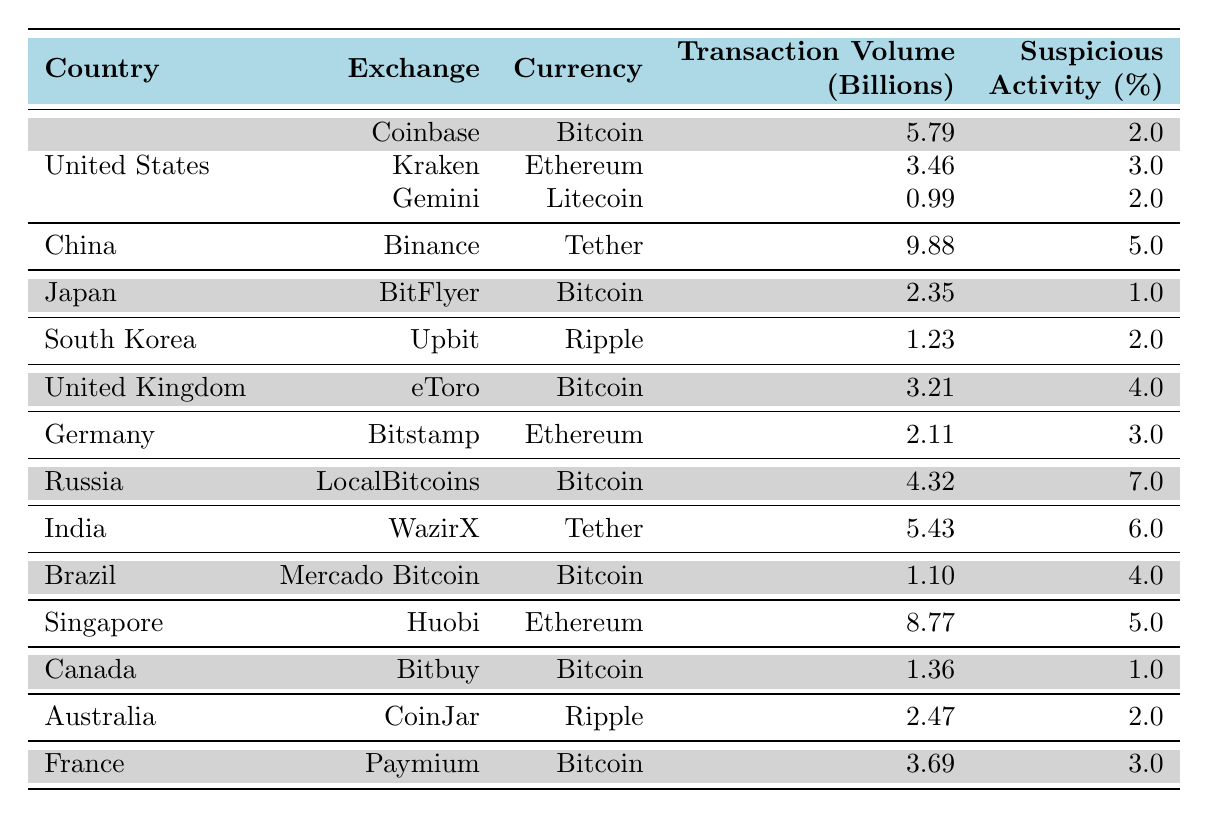What is the total transaction volume for Bitcoin across all exchanges in the United States? To find the total transaction volume for Bitcoin in the United States, we sum the transaction volumes for all entries where the country is "United States" and the currency is "Bitcoin." The values are 5.79 billion (Coinbase) and 0.99 billion (Gemini). Thus, the total is 5.79 + 0.99 = 6.78 billion.
Answer: 6.78 Which exchange has the highest transaction volume for Ethereum? By examining the table, we look for entries where the currency is "Ethereum" and compare their transaction volumes. The only exchanges listed for Ethereum are Kraken (3.46 billion) and Bitstamp (2.11 billion). Since 3.46 billion is greater, the highest transaction volume for Ethereum is on Kraken.
Answer: Kraken Is there a suspicious activity flag greater than 6.0% for any country’s exchanges? We check the suspicious activity flags for all entries in the table. The flags listed are 7.0% for Russia, 6.0% for India, and none exceed this. Thus, there is indeed a country with a flag greater than 6.0%.
Answer: Yes What is the average suspicious activity flag percentage for all exchanges in Canada? There is only one entry for Canada, with a suspicious activity flag of 1.0%. Since the average is based only on this single value, the average is simply the same as the value.
Answer: 1.0 Which country and exchange combination has the highest suspicious activity percentage? We can identify the highest suspicious activity percentage by reviewing all entries. The maximum value is found in the Russia entry for LocalBitcoins, with a suspicious activity flag of 7.0%. Hence, the corresponding country and exchange combination is Russia and LocalBitcoins.
Answer: Russia and LocalBitcoins How much higher is the total transaction volume for Tether compared to Bitcoin across exchanges in Japan and China? We first find the transaction volumes for Tether and Bitcoin in Japan and China. In China, Tether's transaction volume is 9.88 billion. There are no Bitcoin transactions listed for Japan, but for China, it's 0.00 billion. Therefore, we compare Tether (9.88) with Bitcoin (2.35 billion from Japan and 4.32 billion from Russia). The total for Tether (9.88) is higher than the total Bitcoin volume (2.35 + 4.32 = 6.67). Thus, the difference is 9.88 - 6.67 = 3.21 billion.
Answer: 3.21 billion What is the total transaction volume for all exchanges in European countries? We consider the countries classified as European in this dataset (Germany, United Kingdom, and France), noting their transaction volumes: 2.11 billion (Germany), 3.21 billion (United Kingdom), and 3.69 billion (France). The total is 2.11 + 3.21 + 3.69 = 9.01 billion.
Answer: 9.01 billion Does the exchange Upbit have a higher suspicious activity percentage than BitFlyer? By comparing their entries, Upbit (2.0%) and BitFlyer (1.0%) show that Upbit indeed has a higher suspicious activity percentage than BitFlyer.
Answer: Yes 